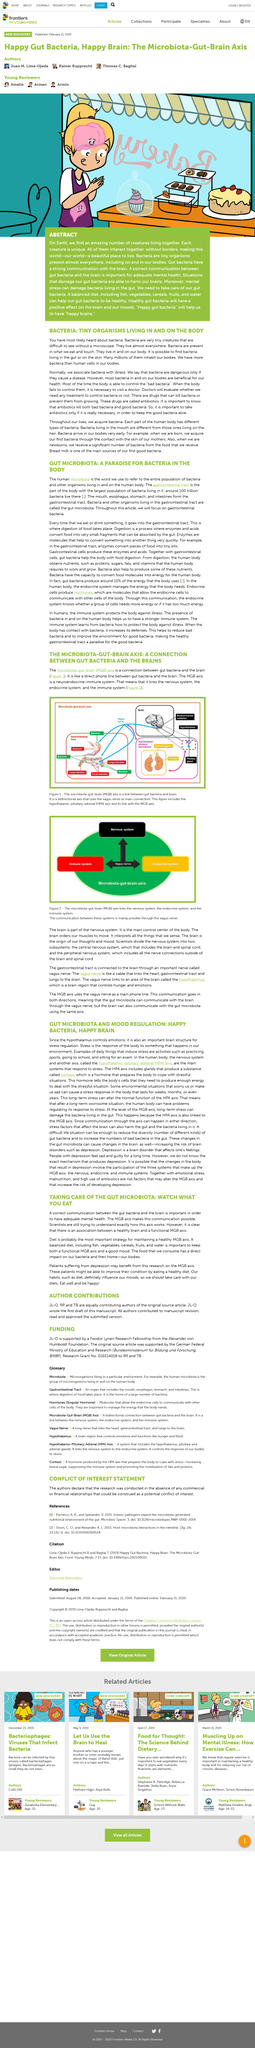Specify some key components in this picture. No, not all bacteria are the same. The hypothalamus plays a crucial role in the regulation of stress, as it is responsible for controlling emotions and is an important part of the brain structure. Bacteria can be dangerous only if they cause disease. The HPA axis includes glands that produce cortisol, a substance that is vital for maintaining normal physiological functions. Bacteria are microscopic organisms that are difficult to observe without the aid of a microscope. They are a diverse group of organisms that are found in a variety of environments, including soil, water, and the human body. Despite their small size, bacteria play important roles in many biological processes and are essential for maintaining the health of ecosystems. 